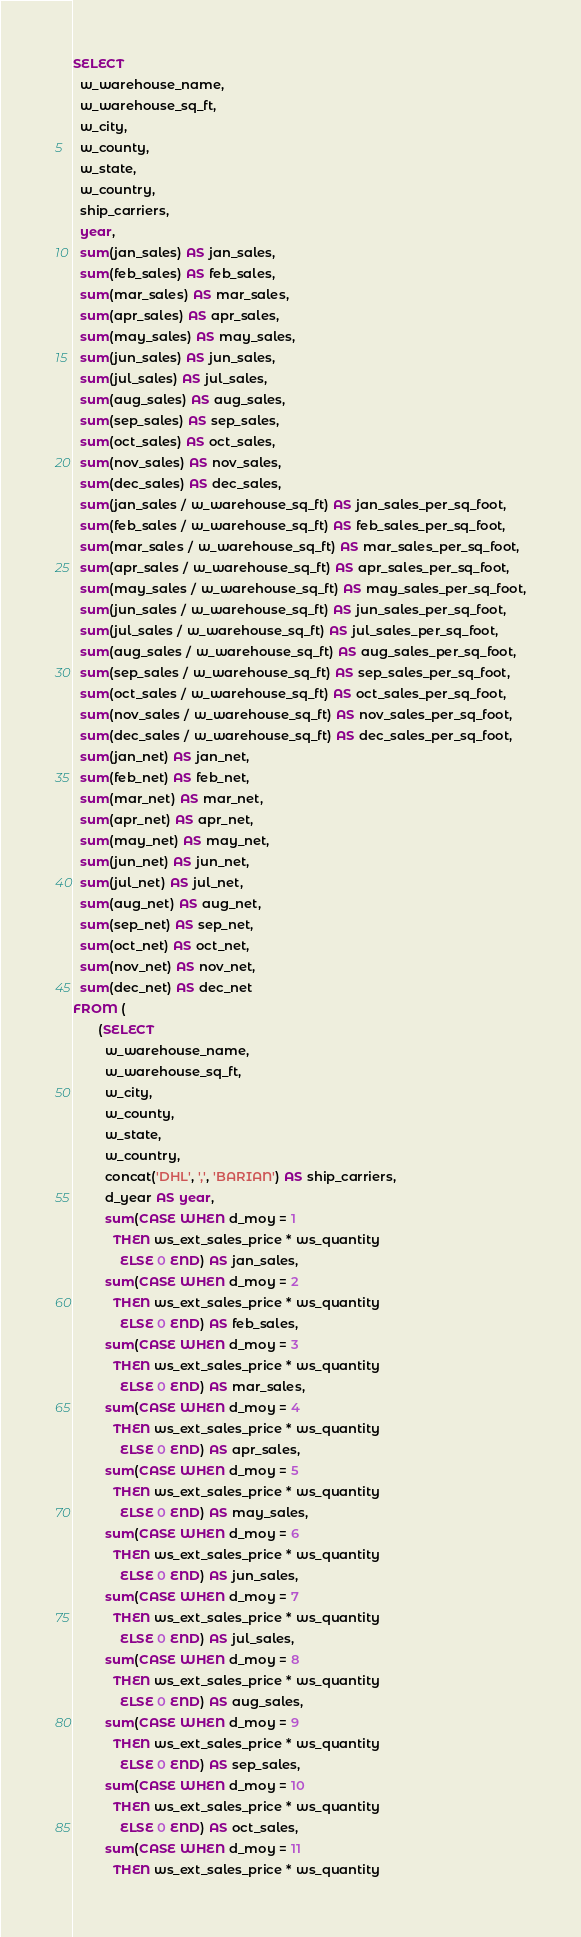Convert code to text. <code><loc_0><loc_0><loc_500><loc_500><_SQL_>SELECT
  w_warehouse_name,
  w_warehouse_sq_ft,
  w_city,
  w_county,
  w_state,
  w_country,
  ship_carriers,
  year,
  sum(jan_sales) AS jan_sales,
  sum(feb_sales) AS feb_sales,
  sum(mar_sales) AS mar_sales,
  sum(apr_sales) AS apr_sales,
  sum(may_sales) AS may_sales,
  sum(jun_sales) AS jun_sales,
  sum(jul_sales) AS jul_sales,
  sum(aug_sales) AS aug_sales,
  sum(sep_sales) AS sep_sales,
  sum(oct_sales) AS oct_sales,
  sum(nov_sales) AS nov_sales,
  sum(dec_sales) AS dec_sales,
  sum(jan_sales / w_warehouse_sq_ft) AS jan_sales_per_sq_foot,
  sum(feb_sales / w_warehouse_sq_ft) AS feb_sales_per_sq_foot,
  sum(mar_sales / w_warehouse_sq_ft) AS mar_sales_per_sq_foot,
  sum(apr_sales / w_warehouse_sq_ft) AS apr_sales_per_sq_foot,
  sum(may_sales / w_warehouse_sq_ft) AS may_sales_per_sq_foot,
  sum(jun_sales / w_warehouse_sq_ft) AS jun_sales_per_sq_foot,
  sum(jul_sales / w_warehouse_sq_ft) AS jul_sales_per_sq_foot,
  sum(aug_sales / w_warehouse_sq_ft) AS aug_sales_per_sq_foot,
  sum(sep_sales / w_warehouse_sq_ft) AS sep_sales_per_sq_foot,
  sum(oct_sales / w_warehouse_sq_ft) AS oct_sales_per_sq_foot,
  sum(nov_sales / w_warehouse_sq_ft) AS nov_sales_per_sq_foot,
  sum(dec_sales / w_warehouse_sq_ft) AS dec_sales_per_sq_foot,
  sum(jan_net) AS jan_net,
  sum(feb_net) AS feb_net,
  sum(mar_net) AS mar_net,
  sum(apr_net) AS apr_net,
  sum(may_net) AS may_net,
  sum(jun_net) AS jun_net,
  sum(jul_net) AS jul_net,
  sum(aug_net) AS aug_net,
  sum(sep_net) AS sep_net,
  sum(oct_net) AS oct_net,
  sum(nov_net) AS nov_net,
  sum(dec_net) AS dec_net
FROM (
       (SELECT
         w_warehouse_name,
         w_warehouse_sq_ft,
         w_city,
         w_county,
         w_state,
         w_country,
         concat('DHL', ',', 'BARIAN') AS ship_carriers,
         d_year AS year,
         sum(CASE WHEN d_moy = 1
           THEN ws_ext_sales_price * ws_quantity
             ELSE 0 END) AS jan_sales,
         sum(CASE WHEN d_moy = 2
           THEN ws_ext_sales_price * ws_quantity
             ELSE 0 END) AS feb_sales,
         sum(CASE WHEN d_moy = 3
           THEN ws_ext_sales_price * ws_quantity
             ELSE 0 END) AS mar_sales,
         sum(CASE WHEN d_moy = 4
           THEN ws_ext_sales_price * ws_quantity
             ELSE 0 END) AS apr_sales,
         sum(CASE WHEN d_moy = 5
           THEN ws_ext_sales_price * ws_quantity
             ELSE 0 END) AS may_sales,
         sum(CASE WHEN d_moy = 6
           THEN ws_ext_sales_price * ws_quantity
             ELSE 0 END) AS jun_sales,
         sum(CASE WHEN d_moy = 7
           THEN ws_ext_sales_price * ws_quantity
             ELSE 0 END) AS jul_sales,
         sum(CASE WHEN d_moy = 8
           THEN ws_ext_sales_price * ws_quantity
             ELSE 0 END) AS aug_sales,
         sum(CASE WHEN d_moy = 9
           THEN ws_ext_sales_price * ws_quantity
             ELSE 0 END) AS sep_sales,
         sum(CASE WHEN d_moy = 10
           THEN ws_ext_sales_price * ws_quantity
             ELSE 0 END) AS oct_sales,
         sum(CASE WHEN d_moy = 11
           THEN ws_ext_sales_price * ws_quantity</code> 